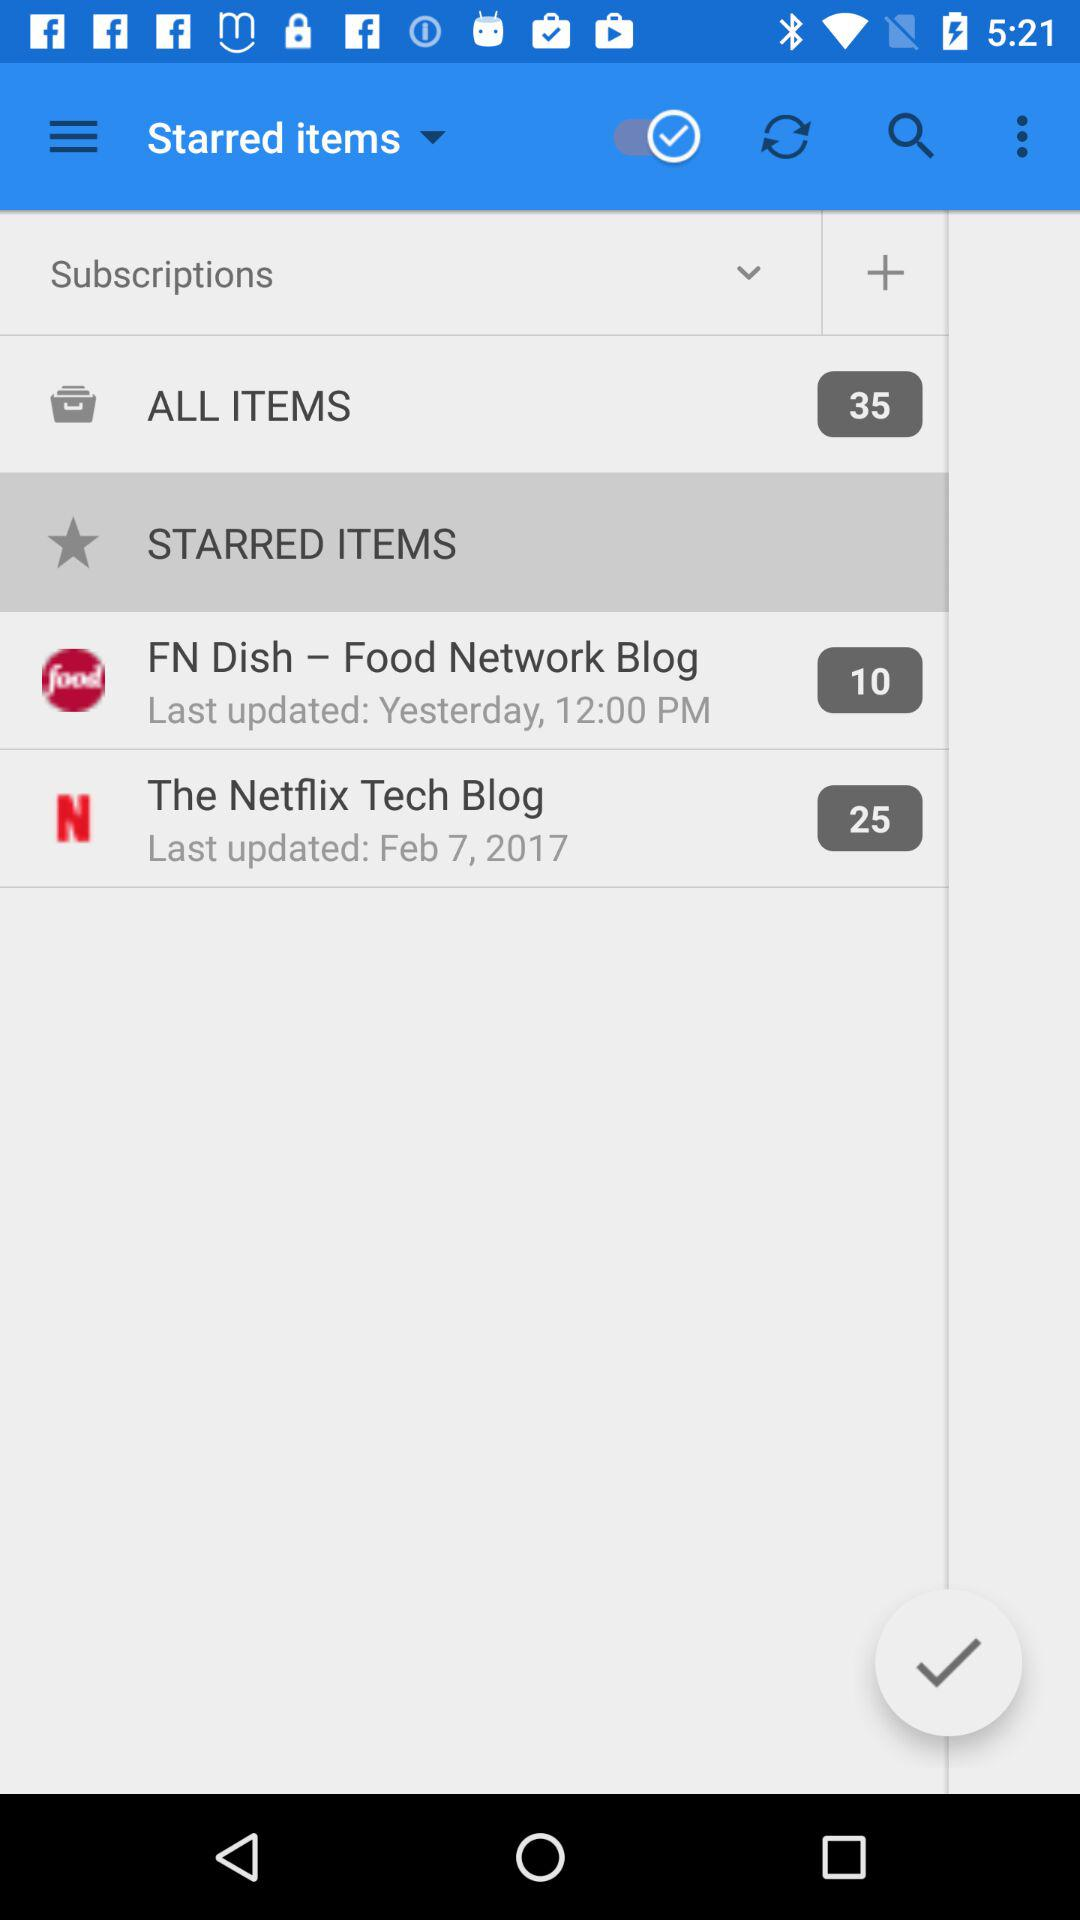How many items in total are there? There are 35 items. 